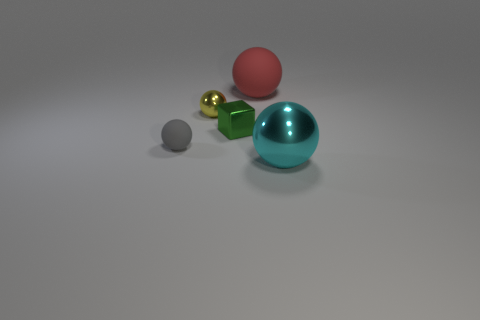Add 2 small rubber spheres. How many objects exist? 7 Subtract all spheres. How many objects are left? 1 Subtract all red balls. How many balls are left? 3 Subtract all small shiny spheres. How many spheres are left? 3 Subtract 2 spheres. How many spheres are left? 2 Subtract all red cylinders. How many cyan spheres are left? 1 Subtract all red matte spheres. Subtract all gray shiny balls. How many objects are left? 4 Add 2 small gray things. How many small gray things are left? 3 Add 2 large brown matte blocks. How many large brown matte blocks exist? 2 Subtract 1 gray spheres. How many objects are left? 4 